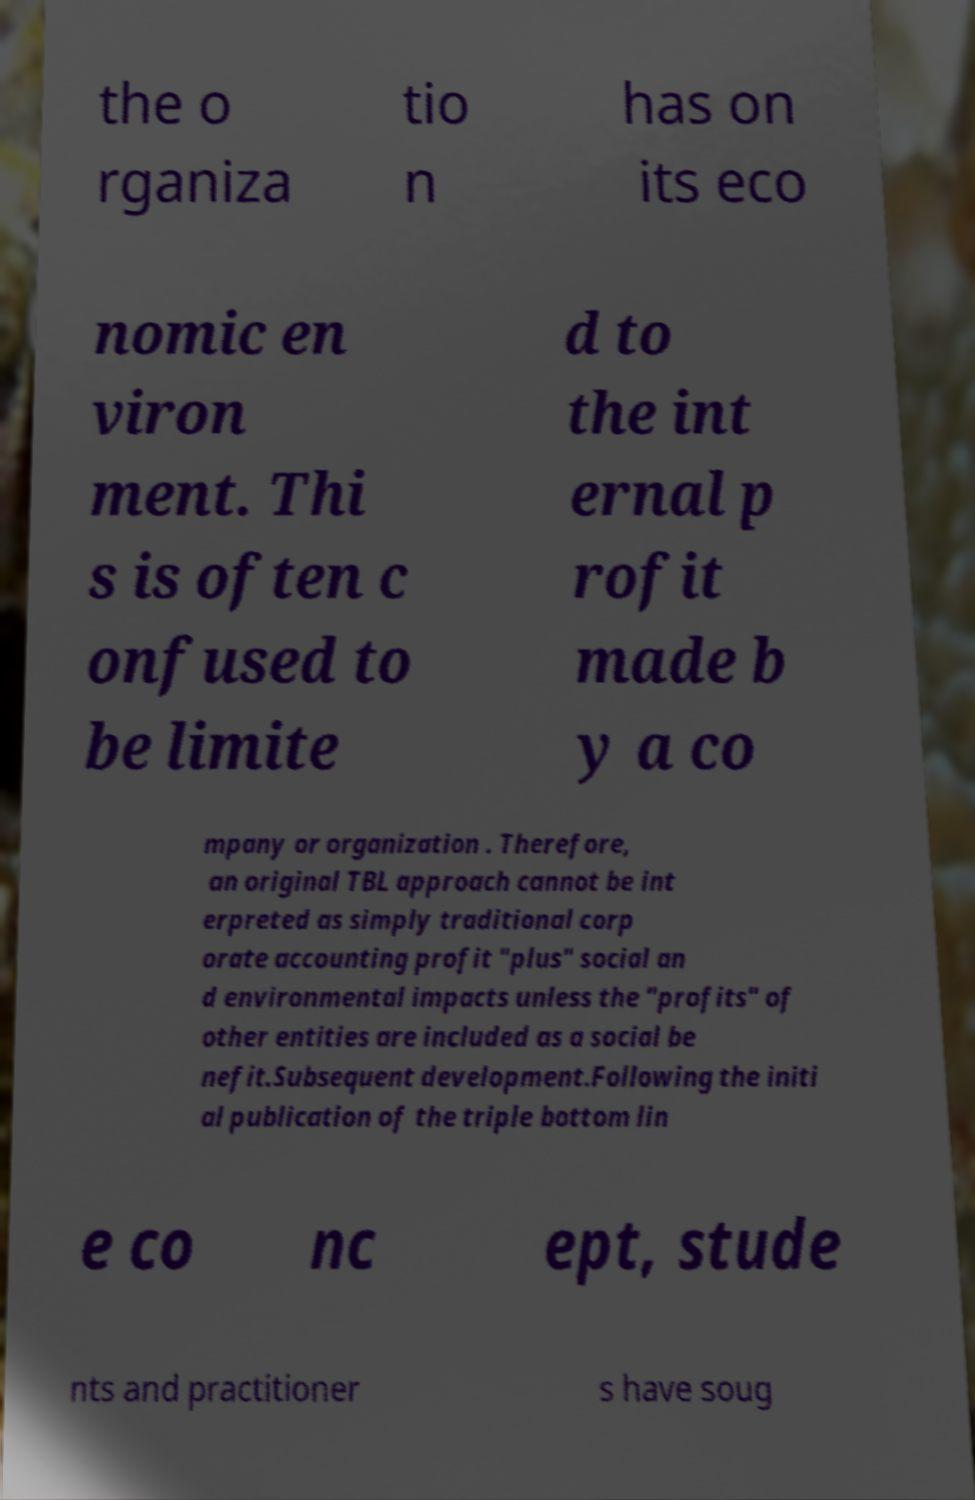Could you extract and type out the text from this image? the o rganiza tio n has on its eco nomic en viron ment. Thi s is often c onfused to be limite d to the int ernal p rofit made b y a co mpany or organization . Therefore, an original TBL approach cannot be int erpreted as simply traditional corp orate accounting profit "plus" social an d environmental impacts unless the "profits" of other entities are included as a social be nefit.Subsequent development.Following the initi al publication of the triple bottom lin e co nc ept, stude nts and practitioner s have soug 